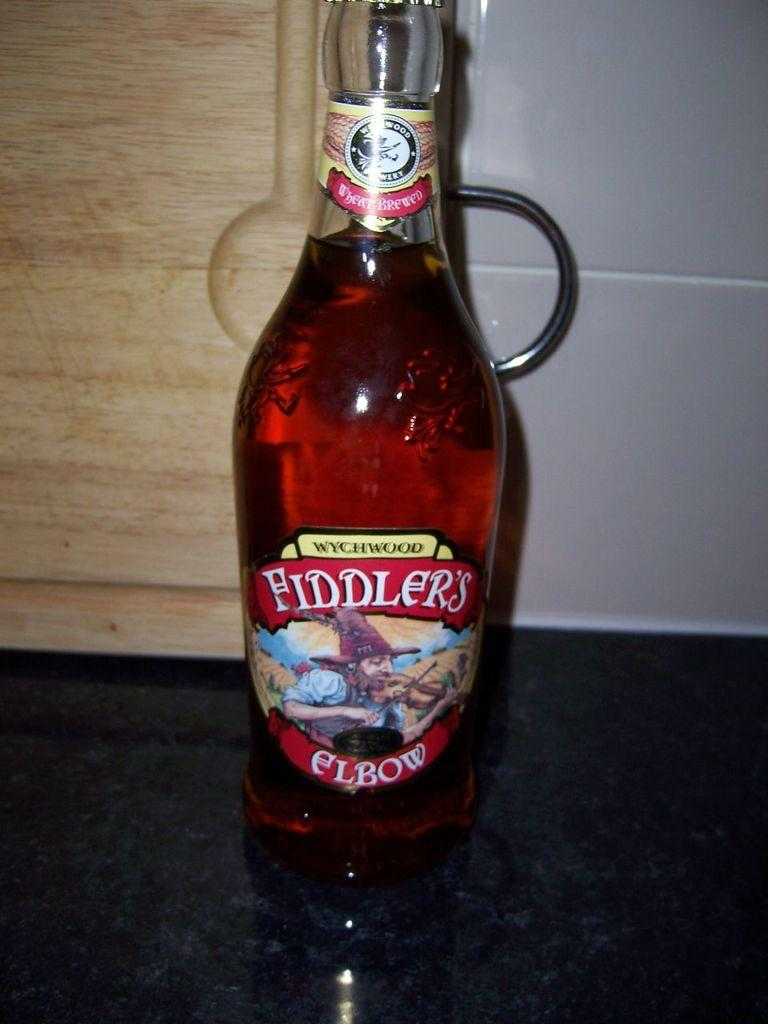What object is placed on the floor in the image? There is a bottle on the floor. What type of structure can be seen in the image? There is a wall in the image. What type of creature is swinging from the bottle in the image? There is no creature present in the image, and the bottle is on the floor, not being swung from. 